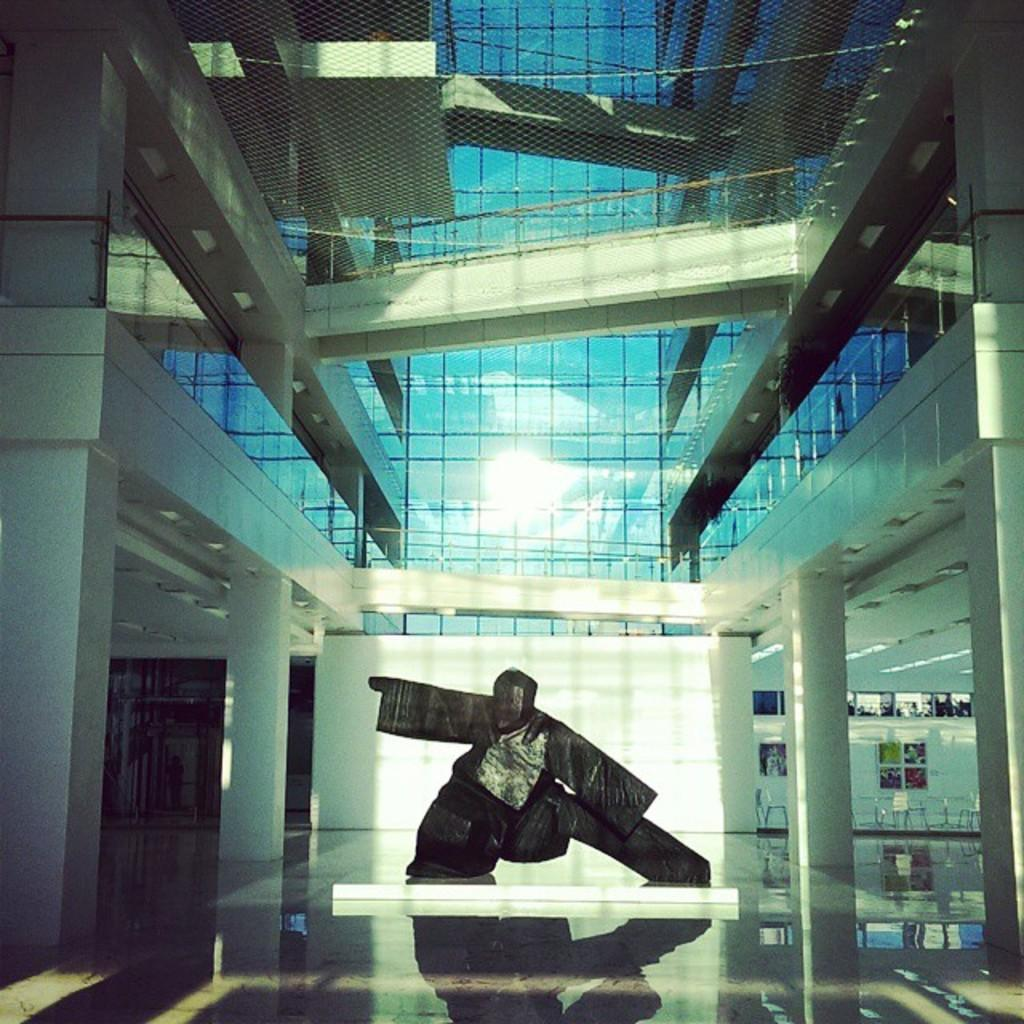What is the main subject in the middle of the image? There is a statue in the middle of the image. What can be seen in the background of the image? There is a building with glass in the background of the image. What architectural features are present on either side of the statue? There are pillars on either side of the statue. What is visible at the bottom of the image? There is a floor visible at the bottom of the image. What advice does the aunt give to the statue in the image? There is no aunt present in the image, so no advice can be given. 